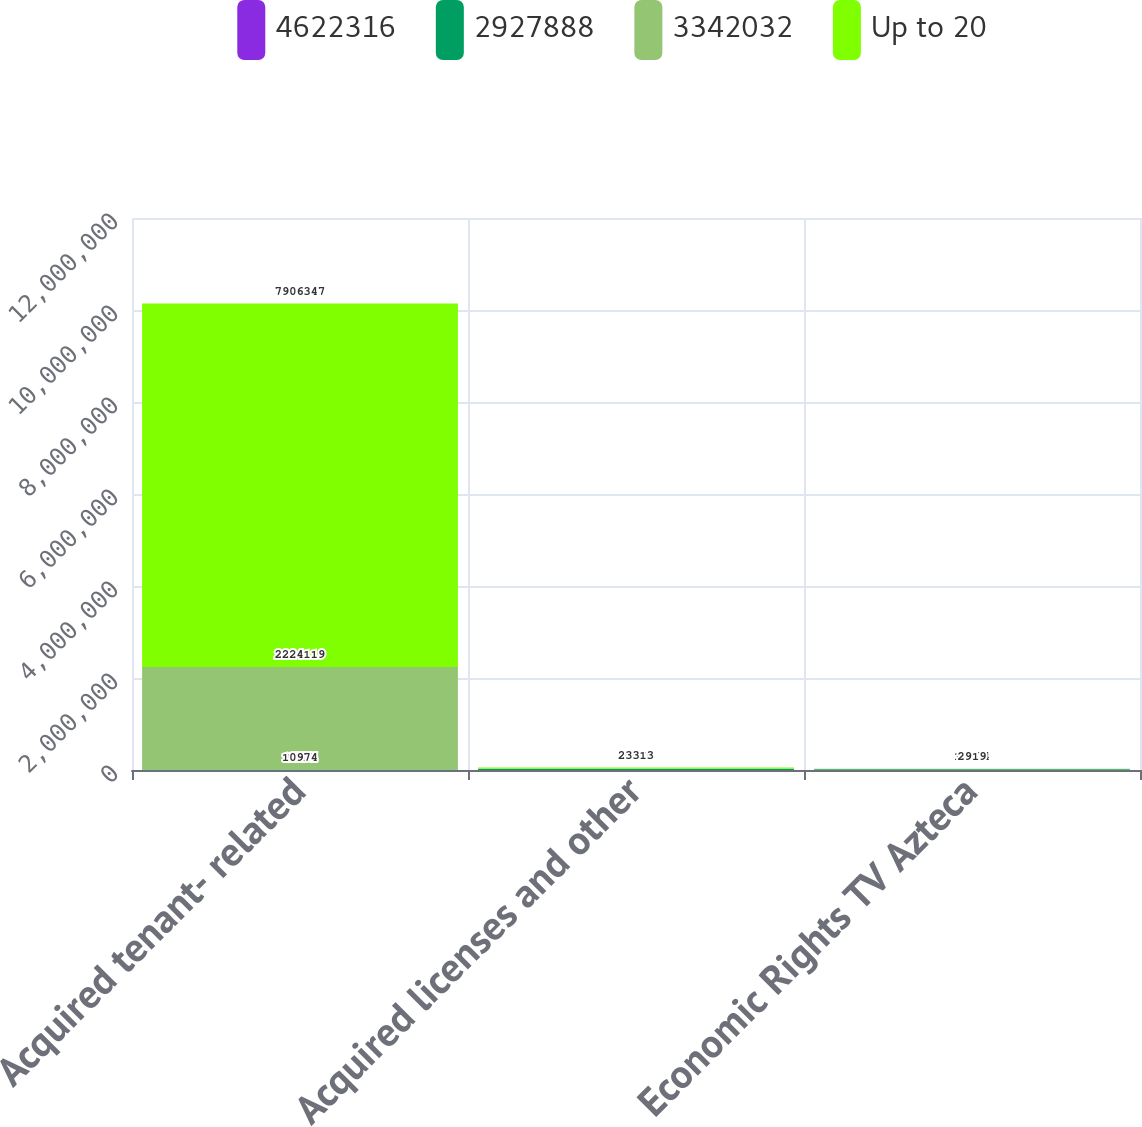<chart> <loc_0><loc_0><loc_500><loc_500><stacked_bar_chart><ecel><fcel>Acquired tenant- related<fcel>Acquired licenses and other<fcel>Economic Rights TV Azteca<nl><fcel>4622316<fcel>1520<fcel>320<fcel>70<nl><fcel>2927888<fcel>10974<fcel>28140<fcel>13893<nl><fcel>3342032<fcel>2.22412e+06<fcel>4827<fcel>10974<nl><fcel>Up to 20<fcel>7.90635e+06<fcel>23313<fcel>2919<nl></chart> 